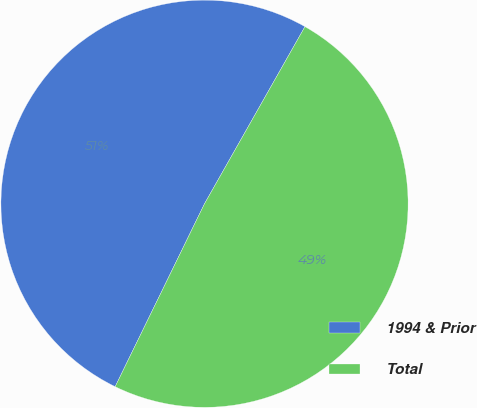<chart> <loc_0><loc_0><loc_500><loc_500><pie_chart><fcel>1994 & Prior<fcel>Total<nl><fcel>50.98%<fcel>49.02%<nl></chart> 